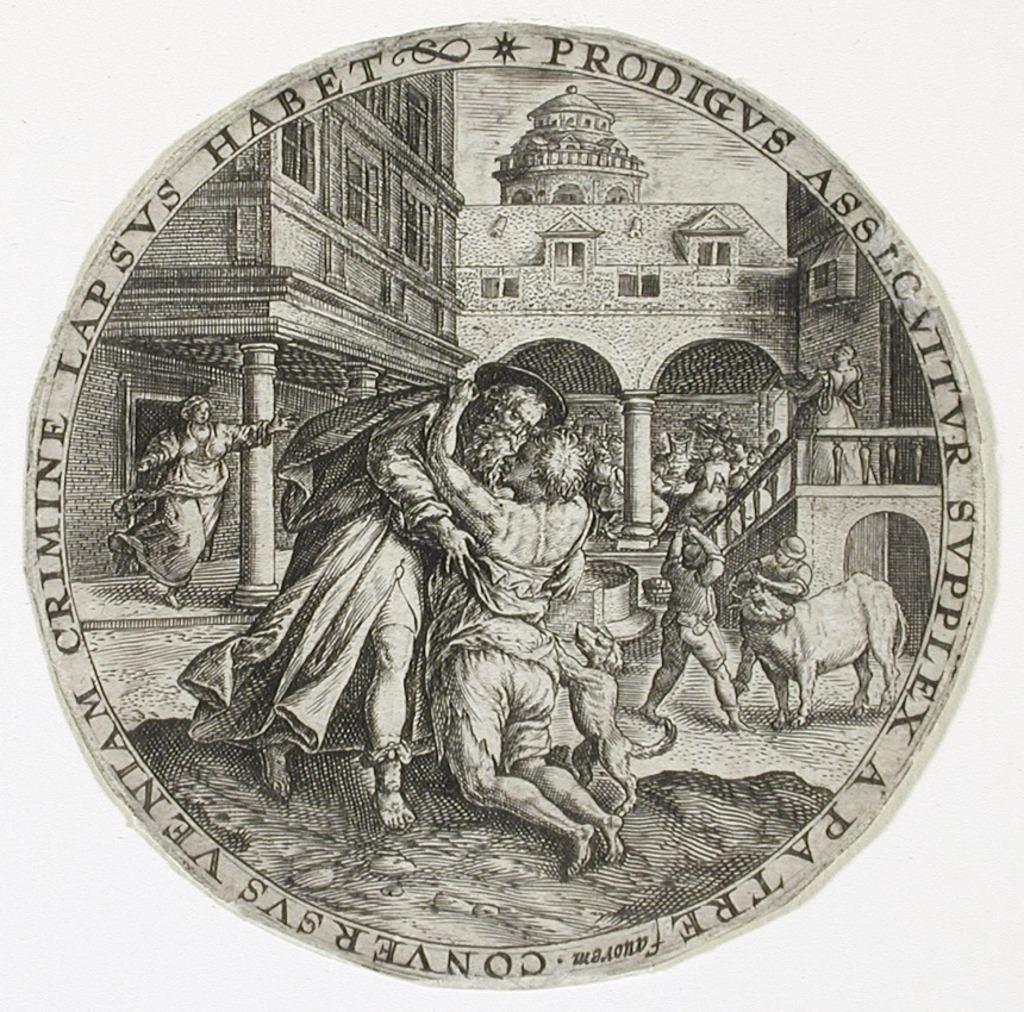Please provide a concise description of this image. In this picture we can see a poster, which is circular in shape. 